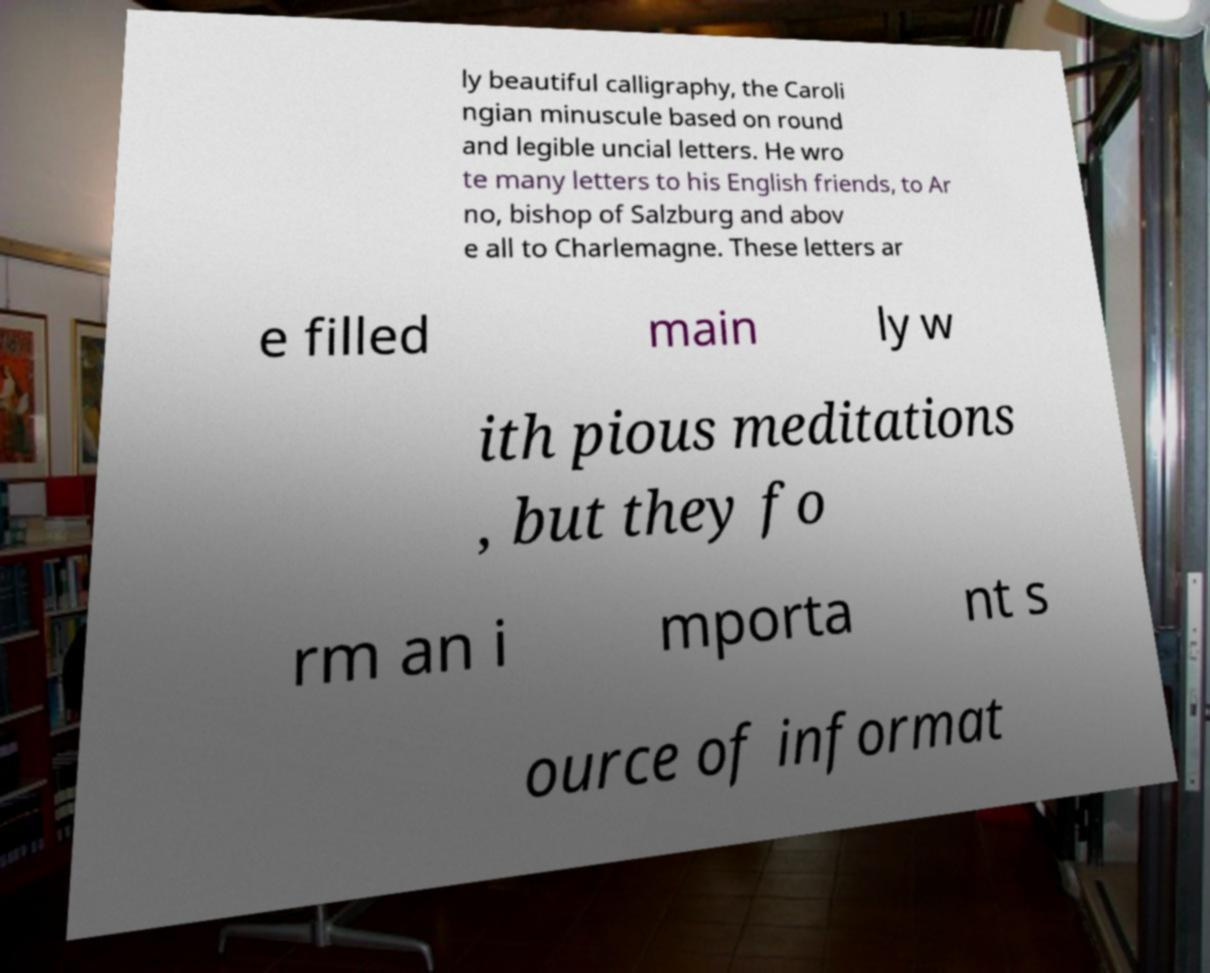Could you extract and type out the text from this image? ly beautiful calligraphy, the Caroli ngian minuscule based on round and legible uncial letters. He wro te many letters to his English friends, to Ar no, bishop of Salzburg and abov e all to Charlemagne. These letters ar e filled main ly w ith pious meditations , but they fo rm an i mporta nt s ource of informat 